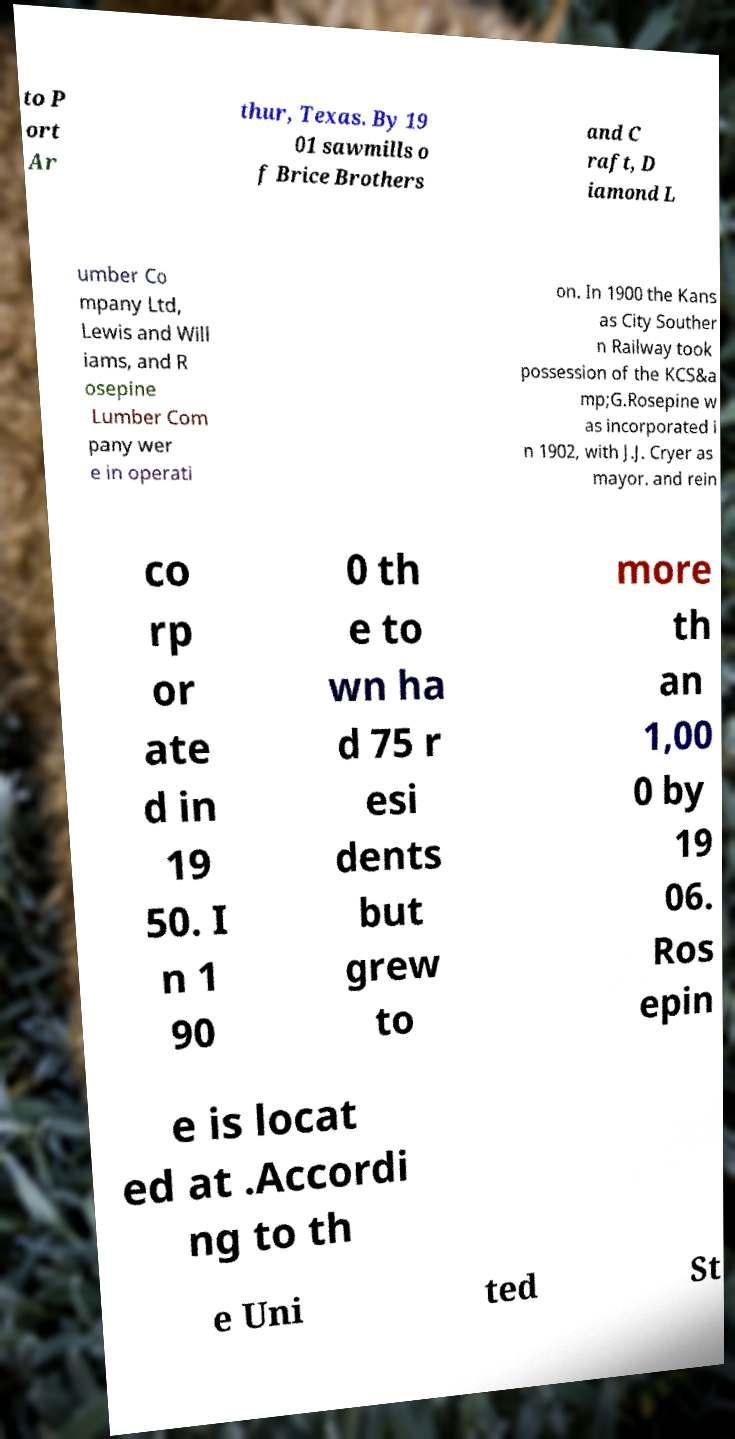Please read and relay the text visible in this image. What does it say? to P ort Ar thur, Texas. By 19 01 sawmills o f Brice Brothers and C raft, D iamond L umber Co mpany Ltd, Lewis and Will iams, and R osepine Lumber Com pany wer e in operati on. In 1900 the Kans as City Souther n Railway took possession of the KCS&a mp;G.Rosepine w as incorporated i n 1902, with J.J. Cryer as mayor. and rein co rp or ate d in 19 50. I n 1 90 0 th e to wn ha d 75 r esi dents but grew to more th an 1,00 0 by 19 06. Ros epin e is locat ed at .Accordi ng to th e Uni ted St 